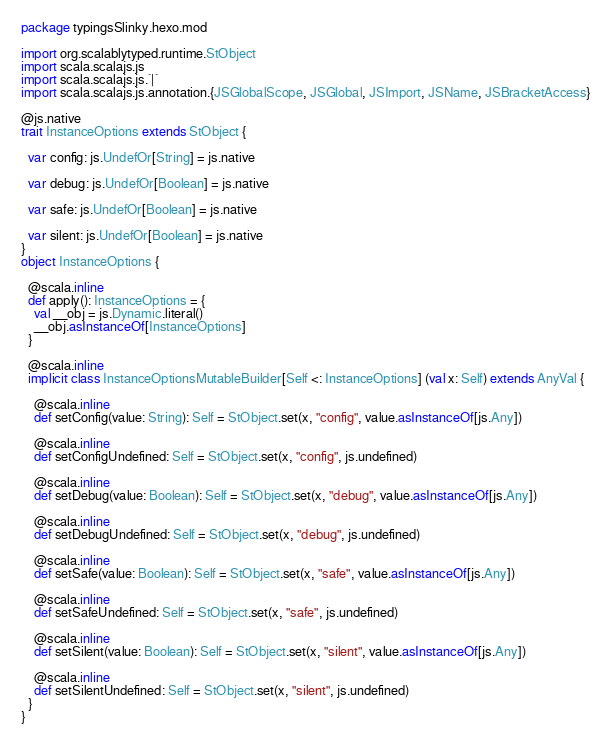<code> <loc_0><loc_0><loc_500><loc_500><_Scala_>package typingsSlinky.hexo.mod

import org.scalablytyped.runtime.StObject
import scala.scalajs.js
import scala.scalajs.js.`|`
import scala.scalajs.js.annotation.{JSGlobalScope, JSGlobal, JSImport, JSName, JSBracketAccess}

@js.native
trait InstanceOptions extends StObject {
  
  var config: js.UndefOr[String] = js.native
  
  var debug: js.UndefOr[Boolean] = js.native
  
  var safe: js.UndefOr[Boolean] = js.native
  
  var silent: js.UndefOr[Boolean] = js.native
}
object InstanceOptions {
  
  @scala.inline
  def apply(): InstanceOptions = {
    val __obj = js.Dynamic.literal()
    __obj.asInstanceOf[InstanceOptions]
  }
  
  @scala.inline
  implicit class InstanceOptionsMutableBuilder[Self <: InstanceOptions] (val x: Self) extends AnyVal {
    
    @scala.inline
    def setConfig(value: String): Self = StObject.set(x, "config", value.asInstanceOf[js.Any])
    
    @scala.inline
    def setConfigUndefined: Self = StObject.set(x, "config", js.undefined)
    
    @scala.inline
    def setDebug(value: Boolean): Self = StObject.set(x, "debug", value.asInstanceOf[js.Any])
    
    @scala.inline
    def setDebugUndefined: Self = StObject.set(x, "debug", js.undefined)
    
    @scala.inline
    def setSafe(value: Boolean): Self = StObject.set(x, "safe", value.asInstanceOf[js.Any])
    
    @scala.inline
    def setSafeUndefined: Self = StObject.set(x, "safe", js.undefined)
    
    @scala.inline
    def setSilent(value: Boolean): Self = StObject.set(x, "silent", value.asInstanceOf[js.Any])
    
    @scala.inline
    def setSilentUndefined: Self = StObject.set(x, "silent", js.undefined)
  }
}
</code> 